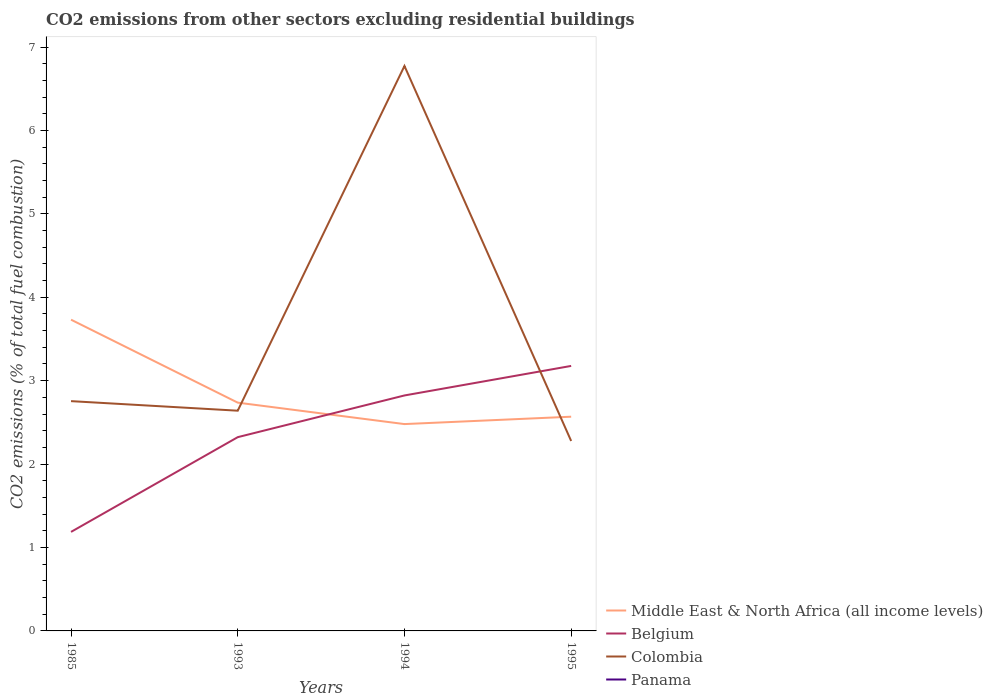Does the line corresponding to Colombia intersect with the line corresponding to Belgium?
Provide a short and direct response. Yes. What is the total total CO2 emitted in Middle East & North Africa (all income levels) in the graph?
Provide a succinct answer. -0.09. What is the difference between the highest and the second highest total CO2 emitted in Colombia?
Your answer should be very brief. 4.5. What is the difference between the highest and the lowest total CO2 emitted in Belgium?
Keep it short and to the point. 2. Is the total CO2 emitted in Colombia strictly greater than the total CO2 emitted in Belgium over the years?
Offer a terse response. No. How many lines are there?
Ensure brevity in your answer.  4. How many years are there in the graph?
Your answer should be compact. 4. Are the values on the major ticks of Y-axis written in scientific E-notation?
Provide a short and direct response. No. Does the graph contain grids?
Your answer should be compact. No. What is the title of the graph?
Keep it short and to the point. CO2 emissions from other sectors excluding residential buildings. Does "Turkmenistan" appear as one of the legend labels in the graph?
Provide a succinct answer. No. What is the label or title of the X-axis?
Provide a short and direct response. Years. What is the label or title of the Y-axis?
Your response must be concise. CO2 emissions (% of total fuel combustion). What is the CO2 emissions (% of total fuel combustion) of Middle East & North Africa (all income levels) in 1985?
Your answer should be very brief. 3.73. What is the CO2 emissions (% of total fuel combustion) in Belgium in 1985?
Provide a succinct answer. 1.19. What is the CO2 emissions (% of total fuel combustion) of Colombia in 1985?
Give a very brief answer. 2.75. What is the CO2 emissions (% of total fuel combustion) of Panama in 1985?
Make the answer very short. 5.15902892483809e-16. What is the CO2 emissions (% of total fuel combustion) of Middle East & North Africa (all income levels) in 1993?
Your answer should be compact. 2.74. What is the CO2 emissions (% of total fuel combustion) in Belgium in 1993?
Your answer should be compact. 2.32. What is the CO2 emissions (% of total fuel combustion) in Colombia in 1993?
Offer a terse response. 2.64. What is the CO2 emissions (% of total fuel combustion) of Middle East & North Africa (all income levels) in 1994?
Keep it short and to the point. 2.48. What is the CO2 emissions (% of total fuel combustion) in Belgium in 1994?
Provide a succinct answer. 2.82. What is the CO2 emissions (% of total fuel combustion) of Colombia in 1994?
Your answer should be compact. 6.77. What is the CO2 emissions (% of total fuel combustion) of Panama in 1994?
Ensure brevity in your answer.  3.65204942310907e-16. What is the CO2 emissions (% of total fuel combustion) in Middle East & North Africa (all income levels) in 1995?
Offer a terse response. 2.57. What is the CO2 emissions (% of total fuel combustion) of Belgium in 1995?
Offer a terse response. 3.18. What is the CO2 emissions (% of total fuel combustion) of Colombia in 1995?
Your answer should be compact. 2.28. Across all years, what is the maximum CO2 emissions (% of total fuel combustion) of Middle East & North Africa (all income levels)?
Ensure brevity in your answer.  3.73. Across all years, what is the maximum CO2 emissions (% of total fuel combustion) of Belgium?
Offer a very short reply. 3.18. Across all years, what is the maximum CO2 emissions (% of total fuel combustion) in Colombia?
Keep it short and to the point. 6.77. Across all years, what is the maximum CO2 emissions (% of total fuel combustion) in Panama?
Offer a terse response. 5.15902892483809e-16. Across all years, what is the minimum CO2 emissions (% of total fuel combustion) in Middle East & North Africa (all income levels)?
Provide a succinct answer. 2.48. Across all years, what is the minimum CO2 emissions (% of total fuel combustion) of Belgium?
Offer a very short reply. 1.19. Across all years, what is the minimum CO2 emissions (% of total fuel combustion) of Colombia?
Your answer should be very brief. 2.28. What is the total CO2 emissions (% of total fuel combustion) in Middle East & North Africa (all income levels) in the graph?
Offer a very short reply. 11.52. What is the total CO2 emissions (% of total fuel combustion) in Belgium in the graph?
Your answer should be very brief. 9.51. What is the total CO2 emissions (% of total fuel combustion) in Colombia in the graph?
Give a very brief answer. 14.44. What is the difference between the CO2 emissions (% of total fuel combustion) of Belgium in 1985 and that in 1993?
Keep it short and to the point. -1.14. What is the difference between the CO2 emissions (% of total fuel combustion) in Colombia in 1985 and that in 1993?
Your answer should be very brief. 0.11. What is the difference between the CO2 emissions (% of total fuel combustion) of Middle East & North Africa (all income levels) in 1985 and that in 1994?
Offer a terse response. 1.25. What is the difference between the CO2 emissions (% of total fuel combustion) in Belgium in 1985 and that in 1994?
Provide a succinct answer. -1.64. What is the difference between the CO2 emissions (% of total fuel combustion) in Colombia in 1985 and that in 1994?
Give a very brief answer. -4.02. What is the difference between the CO2 emissions (% of total fuel combustion) of Panama in 1985 and that in 1994?
Keep it short and to the point. 0. What is the difference between the CO2 emissions (% of total fuel combustion) of Middle East & North Africa (all income levels) in 1985 and that in 1995?
Provide a succinct answer. 1.16. What is the difference between the CO2 emissions (% of total fuel combustion) of Belgium in 1985 and that in 1995?
Make the answer very short. -1.99. What is the difference between the CO2 emissions (% of total fuel combustion) in Colombia in 1985 and that in 1995?
Offer a very short reply. 0.48. What is the difference between the CO2 emissions (% of total fuel combustion) in Middle East & North Africa (all income levels) in 1993 and that in 1994?
Provide a short and direct response. 0.26. What is the difference between the CO2 emissions (% of total fuel combustion) of Belgium in 1993 and that in 1994?
Provide a short and direct response. -0.5. What is the difference between the CO2 emissions (% of total fuel combustion) in Colombia in 1993 and that in 1994?
Offer a very short reply. -4.13. What is the difference between the CO2 emissions (% of total fuel combustion) in Middle East & North Africa (all income levels) in 1993 and that in 1995?
Provide a succinct answer. 0.17. What is the difference between the CO2 emissions (% of total fuel combustion) of Belgium in 1993 and that in 1995?
Keep it short and to the point. -0.85. What is the difference between the CO2 emissions (% of total fuel combustion) in Colombia in 1993 and that in 1995?
Offer a terse response. 0.36. What is the difference between the CO2 emissions (% of total fuel combustion) in Middle East & North Africa (all income levels) in 1994 and that in 1995?
Offer a very short reply. -0.09. What is the difference between the CO2 emissions (% of total fuel combustion) of Belgium in 1994 and that in 1995?
Ensure brevity in your answer.  -0.35. What is the difference between the CO2 emissions (% of total fuel combustion) in Colombia in 1994 and that in 1995?
Give a very brief answer. 4.5. What is the difference between the CO2 emissions (% of total fuel combustion) of Middle East & North Africa (all income levels) in 1985 and the CO2 emissions (% of total fuel combustion) of Belgium in 1993?
Your answer should be compact. 1.41. What is the difference between the CO2 emissions (% of total fuel combustion) of Middle East & North Africa (all income levels) in 1985 and the CO2 emissions (% of total fuel combustion) of Colombia in 1993?
Provide a short and direct response. 1.09. What is the difference between the CO2 emissions (% of total fuel combustion) in Belgium in 1985 and the CO2 emissions (% of total fuel combustion) in Colombia in 1993?
Offer a very short reply. -1.45. What is the difference between the CO2 emissions (% of total fuel combustion) of Middle East & North Africa (all income levels) in 1985 and the CO2 emissions (% of total fuel combustion) of Belgium in 1994?
Your answer should be compact. 0.91. What is the difference between the CO2 emissions (% of total fuel combustion) of Middle East & North Africa (all income levels) in 1985 and the CO2 emissions (% of total fuel combustion) of Colombia in 1994?
Make the answer very short. -3.04. What is the difference between the CO2 emissions (% of total fuel combustion) of Middle East & North Africa (all income levels) in 1985 and the CO2 emissions (% of total fuel combustion) of Panama in 1994?
Make the answer very short. 3.73. What is the difference between the CO2 emissions (% of total fuel combustion) in Belgium in 1985 and the CO2 emissions (% of total fuel combustion) in Colombia in 1994?
Keep it short and to the point. -5.59. What is the difference between the CO2 emissions (% of total fuel combustion) of Belgium in 1985 and the CO2 emissions (% of total fuel combustion) of Panama in 1994?
Offer a very short reply. 1.19. What is the difference between the CO2 emissions (% of total fuel combustion) in Colombia in 1985 and the CO2 emissions (% of total fuel combustion) in Panama in 1994?
Offer a terse response. 2.75. What is the difference between the CO2 emissions (% of total fuel combustion) in Middle East & North Africa (all income levels) in 1985 and the CO2 emissions (% of total fuel combustion) in Belgium in 1995?
Provide a short and direct response. 0.55. What is the difference between the CO2 emissions (% of total fuel combustion) in Middle East & North Africa (all income levels) in 1985 and the CO2 emissions (% of total fuel combustion) in Colombia in 1995?
Give a very brief answer. 1.45. What is the difference between the CO2 emissions (% of total fuel combustion) in Belgium in 1985 and the CO2 emissions (% of total fuel combustion) in Colombia in 1995?
Offer a very short reply. -1.09. What is the difference between the CO2 emissions (% of total fuel combustion) of Middle East & North Africa (all income levels) in 1993 and the CO2 emissions (% of total fuel combustion) of Belgium in 1994?
Offer a very short reply. -0.09. What is the difference between the CO2 emissions (% of total fuel combustion) of Middle East & North Africa (all income levels) in 1993 and the CO2 emissions (% of total fuel combustion) of Colombia in 1994?
Your answer should be very brief. -4.04. What is the difference between the CO2 emissions (% of total fuel combustion) of Middle East & North Africa (all income levels) in 1993 and the CO2 emissions (% of total fuel combustion) of Panama in 1994?
Keep it short and to the point. 2.74. What is the difference between the CO2 emissions (% of total fuel combustion) in Belgium in 1993 and the CO2 emissions (% of total fuel combustion) in Colombia in 1994?
Offer a very short reply. -4.45. What is the difference between the CO2 emissions (% of total fuel combustion) in Belgium in 1993 and the CO2 emissions (% of total fuel combustion) in Panama in 1994?
Make the answer very short. 2.32. What is the difference between the CO2 emissions (% of total fuel combustion) in Colombia in 1993 and the CO2 emissions (% of total fuel combustion) in Panama in 1994?
Keep it short and to the point. 2.64. What is the difference between the CO2 emissions (% of total fuel combustion) in Middle East & North Africa (all income levels) in 1993 and the CO2 emissions (% of total fuel combustion) in Belgium in 1995?
Provide a short and direct response. -0.44. What is the difference between the CO2 emissions (% of total fuel combustion) in Middle East & North Africa (all income levels) in 1993 and the CO2 emissions (% of total fuel combustion) in Colombia in 1995?
Provide a short and direct response. 0.46. What is the difference between the CO2 emissions (% of total fuel combustion) of Belgium in 1993 and the CO2 emissions (% of total fuel combustion) of Colombia in 1995?
Give a very brief answer. 0.05. What is the difference between the CO2 emissions (% of total fuel combustion) in Middle East & North Africa (all income levels) in 1994 and the CO2 emissions (% of total fuel combustion) in Belgium in 1995?
Give a very brief answer. -0.7. What is the difference between the CO2 emissions (% of total fuel combustion) of Middle East & North Africa (all income levels) in 1994 and the CO2 emissions (% of total fuel combustion) of Colombia in 1995?
Make the answer very short. 0.2. What is the difference between the CO2 emissions (% of total fuel combustion) of Belgium in 1994 and the CO2 emissions (% of total fuel combustion) of Colombia in 1995?
Your response must be concise. 0.55. What is the average CO2 emissions (% of total fuel combustion) of Middle East & North Africa (all income levels) per year?
Ensure brevity in your answer.  2.88. What is the average CO2 emissions (% of total fuel combustion) of Belgium per year?
Provide a short and direct response. 2.38. What is the average CO2 emissions (% of total fuel combustion) of Colombia per year?
Offer a terse response. 3.61. In the year 1985, what is the difference between the CO2 emissions (% of total fuel combustion) of Middle East & North Africa (all income levels) and CO2 emissions (% of total fuel combustion) of Belgium?
Offer a very short reply. 2.54. In the year 1985, what is the difference between the CO2 emissions (% of total fuel combustion) in Middle East & North Africa (all income levels) and CO2 emissions (% of total fuel combustion) in Colombia?
Offer a very short reply. 0.98. In the year 1985, what is the difference between the CO2 emissions (% of total fuel combustion) in Middle East & North Africa (all income levels) and CO2 emissions (% of total fuel combustion) in Panama?
Your response must be concise. 3.73. In the year 1985, what is the difference between the CO2 emissions (% of total fuel combustion) in Belgium and CO2 emissions (% of total fuel combustion) in Colombia?
Offer a terse response. -1.57. In the year 1985, what is the difference between the CO2 emissions (% of total fuel combustion) of Belgium and CO2 emissions (% of total fuel combustion) of Panama?
Offer a very short reply. 1.19. In the year 1985, what is the difference between the CO2 emissions (% of total fuel combustion) in Colombia and CO2 emissions (% of total fuel combustion) in Panama?
Offer a very short reply. 2.75. In the year 1993, what is the difference between the CO2 emissions (% of total fuel combustion) of Middle East & North Africa (all income levels) and CO2 emissions (% of total fuel combustion) of Belgium?
Provide a succinct answer. 0.41. In the year 1993, what is the difference between the CO2 emissions (% of total fuel combustion) in Middle East & North Africa (all income levels) and CO2 emissions (% of total fuel combustion) in Colombia?
Give a very brief answer. 0.1. In the year 1993, what is the difference between the CO2 emissions (% of total fuel combustion) of Belgium and CO2 emissions (% of total fuel combustion) of Colombia?
Keep it short and to the point. -0.32. In the year 1994, what is the difference between the CO2 emissions (% of total fuel combustion) in Middle East & North Africa (all income levels) and CO2 emissions (% of total fuel combustion) in Belgium?
Your answer should be compact. -0.34. In the year 1994, what is the difference between the CO2 emissions (% of total fuel combustion) of Middle East & North Africa (all income levels) and CO2 emissions (% of total fuel combustion) of Colombia?
Your response must be concise. -4.29. In the year 1994, what is the difference between the CO2 emissions (% of total fuel combustion) of Middle East & North Africa (all income levels) and CO2 emissions (% of total fuel combustion) of Panama?
Make the answer very short. 2.48. In the year 1994, what is the difference between the CO2 emissions (% of total fuel combustion) of Belgium and CO2 emissions (% of total fuel combustion) of Colombia?
Your response must be concise. -3.95. In the year 1994, what is the difference between the CO2 emissions (% of total fuel combustion) of Belgium and CO2 emissions (% of total fuel combustion) of Panama?
Provide a succinct answer. 2.82. In the year 1994, what is the difference between the CO2 emissions (% of total fuel combustion) in Colombia and CO2 emissions (% of total fuel combustion) in Panama?
Your response must be concise. 6.77. In the year 1995, what is the difference between the CO2 emissions (% of total fuel combustion) in Middle East & North Africa (all income levels) and CO2 emissions (% of total fuel combustion) in Belgium?
Your response must be concise. -0.61. In the year 1995, what is the difference between the CO2 emissions (% of total fuel combustion) in Middle East & North Africa (all income levels) and CO2 emissions (% of total fuel combustion) in Colombia?
Ensure brevity in your answer.  0.29. In the year 1995, what is the difference between the CO2 emissions (% of total fuel combustion) in Belgium and CO2 emissions (% of total fuel combustion) in Colombia?
Provide a short and direct response. 0.9. What is the ratio of the CO2 emissions (% of total fuel combustion) of Middle East & North Africa (all income levels) in 1985 to that in 1993?
Your answer should be compact. 1.36. What is the ratio of the CO2 emissions (% of total fuel combustion) in Belgium in 1985 to that in 1993?
Give a very brief answer. 0.51. What is the ratio of the CO2 emissions (% of total fuel combustion) in Colombia in 1985 to that in 1993?
Offer a terse response. 1.04. What is the ratio of the CO2 emissions (% of total fuel combustion) in Middle East & North Africa (all income levels) in 1985 to that in 1994?
Offer a terse response. 1.5. What is the ratio of the CO2 emissions (% of total fuel combustion) in Belgium in 1985 to that in 1994?
Your answer should be compact. 0.42. What is the ratio of the CO2 emissions (% of total fuel combustion) of Colombia in 1985 to that in 1994?
Offer a terse response. 0.41. What is the ratio of the CO2 emissions (% of total fuel combustion) in Panama in 1985 to that in 1994?
Ensure brevity in your answer.  1.41. What is the ratio of the CO2 emissions (% of total fuel combustion) in Middle East & North Africa (all income levels) in 1985 to that in 1995?
Ensure brevity in your answer.  1.45. What is the ratio of the CO2 emissions (% of total fuel combustion) of Belgium in 1985 to that in 1995?
Make the answer very short. 0.37. What is the ratio of the CO2 emissions (% of total fuel combustion) of Colombia in 1985 to that in 1995?
Offer a terse response. 1.21. What is the ratio of the CO2 emissions (% of total fuel combustion) of Middle East & North Africa (all income levels) in 1993 to that in 1994?
Keep it short and to the point. 1.1. What is the ratio of the CO2 emissions (% of total fuel combustion) in Belgium in 1993 to that in 1994?
Your answer should be very brief. 0.82. What is the ratio of the CO2 emissions (% of total fuel combustion) in Colombia in 1993 to that in 1994?
Give a very brief answer. 0.39. What is the ratio of the CO2 emissions (% of total fuel combustion) of Middle East & North Africa (all income levels) in 1993 to that in 1995?
Make the answer very short. 1.07. What is the ratio of the CO2 emissions (% of total fuel combustion) in Belgium in 1993 to that in 1995?
Give a very brief answer. 0.73. What is the ratio of the CO2 emissions (% of total fuel combustion) in Colombia in 1993 to that in 1995?
Provide a short and direct response. 1.16. What is the ratio of the CO2 emissions (% of total fuel combustion) of Middle East & North Africa (all income levels) in 1994 to that in 1995?
Offer a very short reply. 0.97. What is the ratio of the CO2 emissions (% of total fuel combustion) of Belgium in 1994 to that in 1995?
Make the answer very short. 0.89. What is the ratio of the CO2 emissions (% of total fuel combustion) in Colombia in 1994 to that in 1995?
Your response must be concise. 2.97. What is the difference between the highest and the second highest CO2 emissions (% of total fuel combustion) of Middle East & North Africa (all income levels)?
Offer a terse response. 0.99. What is the difference between the highest and the second highest CO2 emissions (% of total fuel combustion) in Belgium?
Ensure brevity in your answer.  0.35. What is the difference between the highest and the second highest CO2 emissions (% of total fuel combustion) in Colombia?
Your answer should be compact. 4.02. What is the difference between the highest and the lowest CO2 emissions (% of total fuel combustion) in Middle East & North Africa (all income levels)?
Provide a short and direct response. 1.25. What is the difference between the highest and the lowest CO2 emissions (% of total fuel combustion) of Belgium?
Your response must be concise. 1.99. What is the difference between the highest and the lowest CO2 emissions (% of total fuel combustion) of Colombia?
Ensure brevity in your answer.  4.5. 